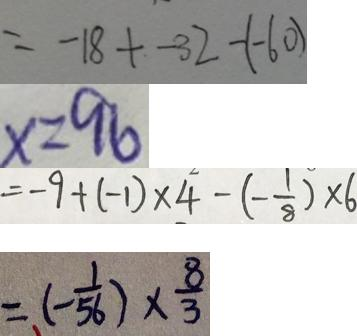Convert formula to latex. <formula><loc_0><loc_0><loc_500><loc_500>= - 1 8 + - 3 2 - ( - 6 0 ) 
 x = 9 6 
 = - 9 + ( - 1 ) \times 4 - ( - \frac { 1 } { 8 } ) \times 6 
 = ( - \frac { 1 } { 5 6 } ) \times \frac { 8 } { 3 }</formula> 